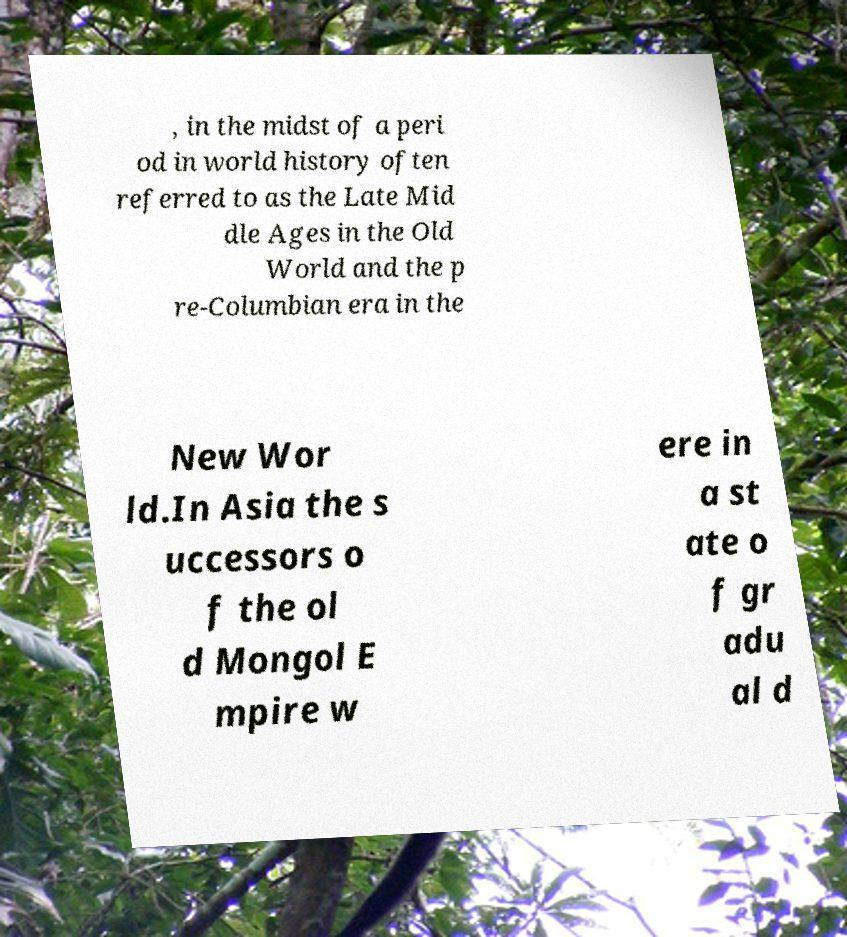For documentation purposes, I need the text within this image transcribed. Could you provide that? , in the midst of a peri od in world history often referred to as the Late Mid dle Ages in the Old World and the p re-Columbian era in the New Wor ld.In Asia the s uccessors o f the ol d Mongol E mpire w ere in a st ate o f gr adu al d 